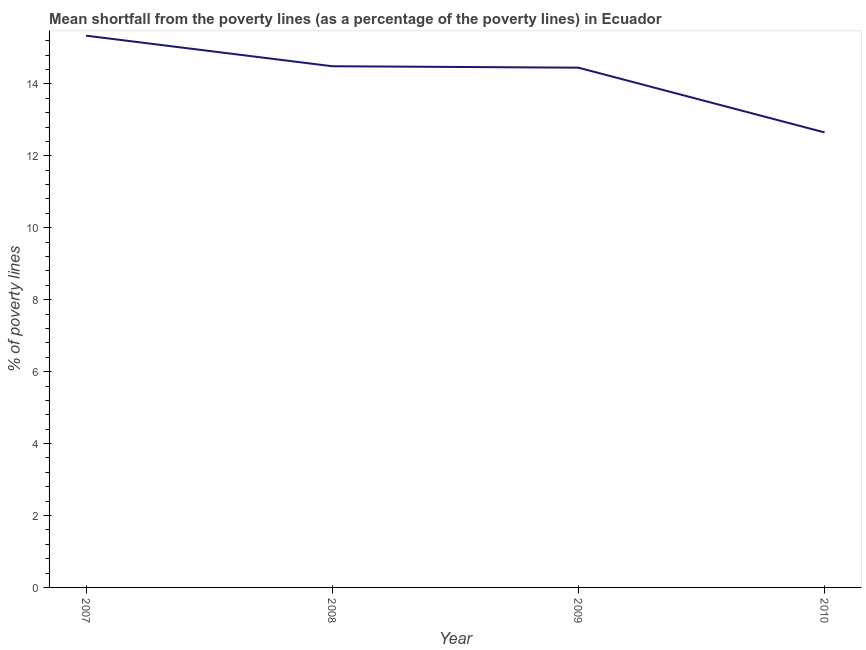What is the poverty gap at national poverty lines in 2008?
Provide a short and direct response. 14.49. Across all years, what is the maximum poverty gap at national poverty lines?
Your answer should be very brief. 15.34. Across all years, what is the minimum poverty gap at national poverty lines?
Your answer should be very brief. 12.65. What is the sum of the poverty gap at national poverty lines?
Ensure brevity in your answer.  56.93. What is the difference between the poverty gap at national poverty lines in 2007 and 2009?
Ensure brevity in your answer.  0.89. What is the average poverty gap at national poverty lines per year?
Offer a terse response. 14.23. What is the median poverty gap at national poverty lines?
Keep it short and to the point. 14.47. In how many years, is the poverty gap at national poverty lines greater than 6.8 %?
Offer a very short reply. 4. Do a majority of the years between 2010 and 2008 (inclusive) have poverty gap at national poverty lines greater than 4.4 %?
Your response must be concise. No. What is the ratio of the poverty gap at national poverty lines in 2008 to that in 2010?
Provide a short and direct response. 1.15. Is the difference between the poverty gap at national poverty lines in 2008 and 2010 greater than the difference between any two years?
Provide a succinct answer. No. What is the difference between the highest and the second highest poverty gap at national poverty lines?
Offer a terse response. 0.85. What is the difference between the highest and the lowest poverty gap at national poverty lines?
Ensure brevity in your answer.  2.69. Does the poverty gap at national poverty lines monotonically increase over the years?
Ensure brevity in your answer.  No. What is the difference between two consecutive major ticks on the Y-axis?
Your answer should be compact. 2. Are the values on the major ticks of Y-axis written in scientific E-notation?
Provide a short and direct response. No. Does the graph contain grids?
Your response must be concise. No. What is the title of the graph?
Ensure brevity in your answer.  Mean shortfall from the poverty lines (as a percentage of the poverty lines) in Ecuador. What is the label or title of the X-axis?
Give a very brief answer. Year. What is the label or title of the Y-axis?
Your answer should be very brief. % of poverty lines. What is the % of poverty lines in 2007?
Offer a terse response. 15.34. What is the % of poverty lines in 2008?
Give a very brief answer. 14.49. What is the % of poverty lines of 2009?
Provide a succinct answer. 14.45. What is the % of poverty lines of 2010?
Ensure brevity in your answer.  12.65. What is the difference between the % of poverty lines in 2007 and 2009?
Offer a terse response. 0.89. What is the difference between the % of poverty lines in 2007 and 2010?
Give a very brief answer. 2.69. What is the difference between the % of poverty lines in 2008 and 2010?
Provide a short and direct response. 1.84. What is the ratio of the % of poverty lines in 2007 to that in 2008?
Your answer should be compact. 1.06. What is the ratio of the % of poverty lines in 2007 to that in 2009?
Offer a terse response. 1.06. What is the ratio of the % of poverty lines in 2007 to that in 2010?
Your answer should be compact. 1.21. What is the ratio of the % of poverty lines in 2008 to that in 2009?
Provide a short and direct response. 1. What is the ratio of the % of poverty lines in 2008 to that in 2010?
Provide a succinct answer. 1.15. What is the ratio of the % of poverty lines in 2009 to that in 2010?
Give a very brief answer. 1.14. 